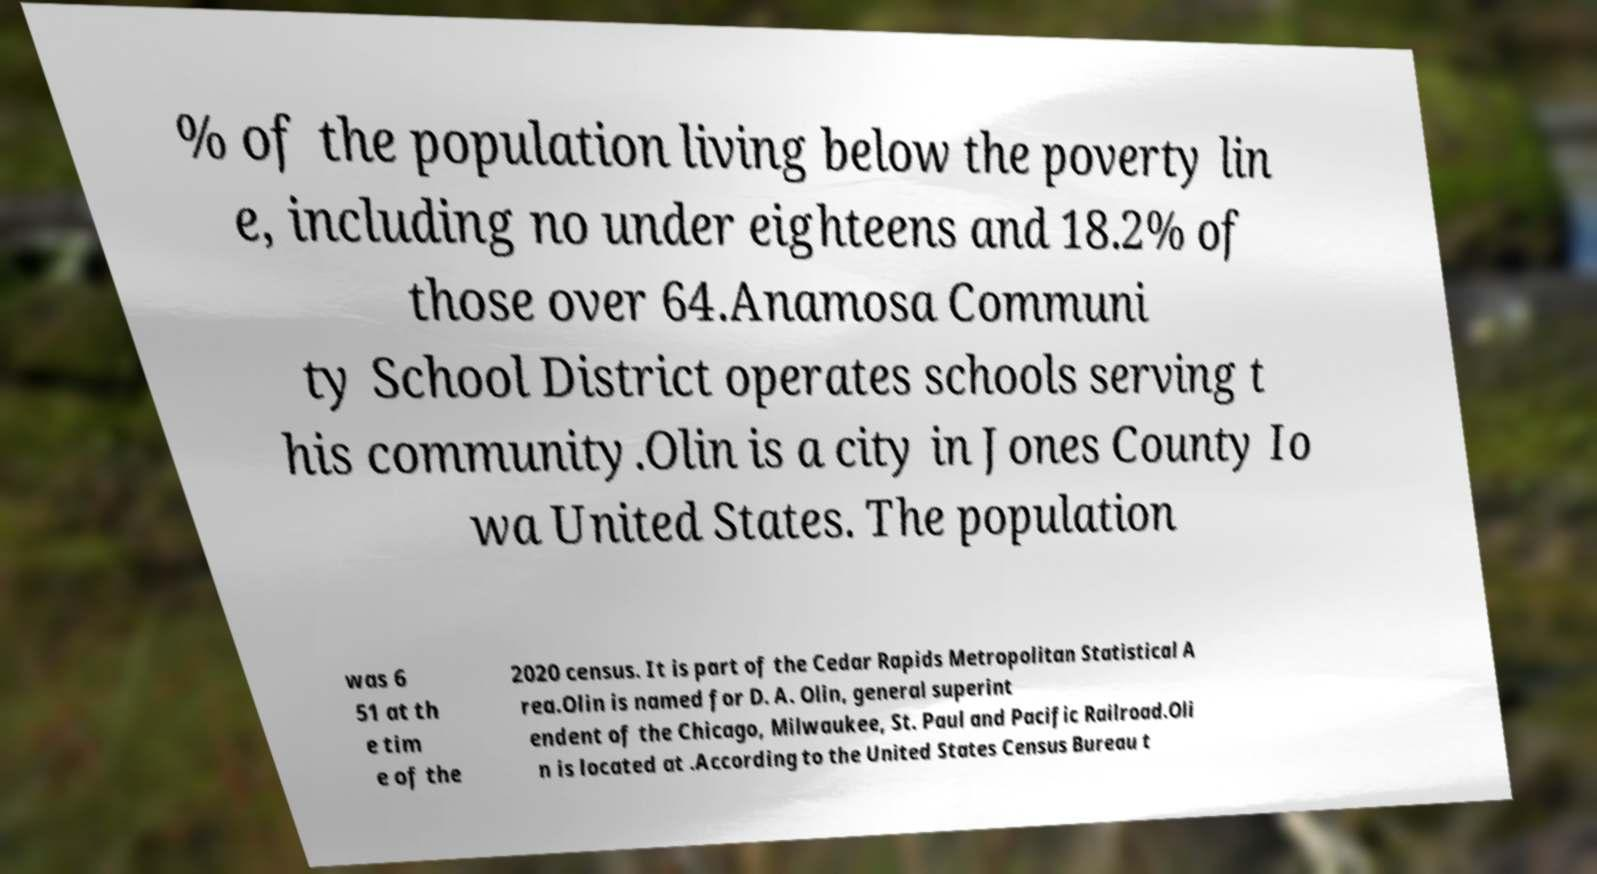Please identify and transcribe the text found in this image. % of the population living below the poverty lin e, including no under eighteens and 18.2% of those over 64.Anamosa Communi ty School District operates schools serving t his community.Olin is a city in Jones County Io wa United States. The population was 6 51 at th e tim e of the 2020 census. It is part of the Cedar Rapids Metropolitan Statistical A rea.Olin is named for D. A. Olin, general superint endent of the Chicago, Milwaukee, St. Paul and Pacific Railroad.Oli n is located at .According to the United States Census Bureau t 